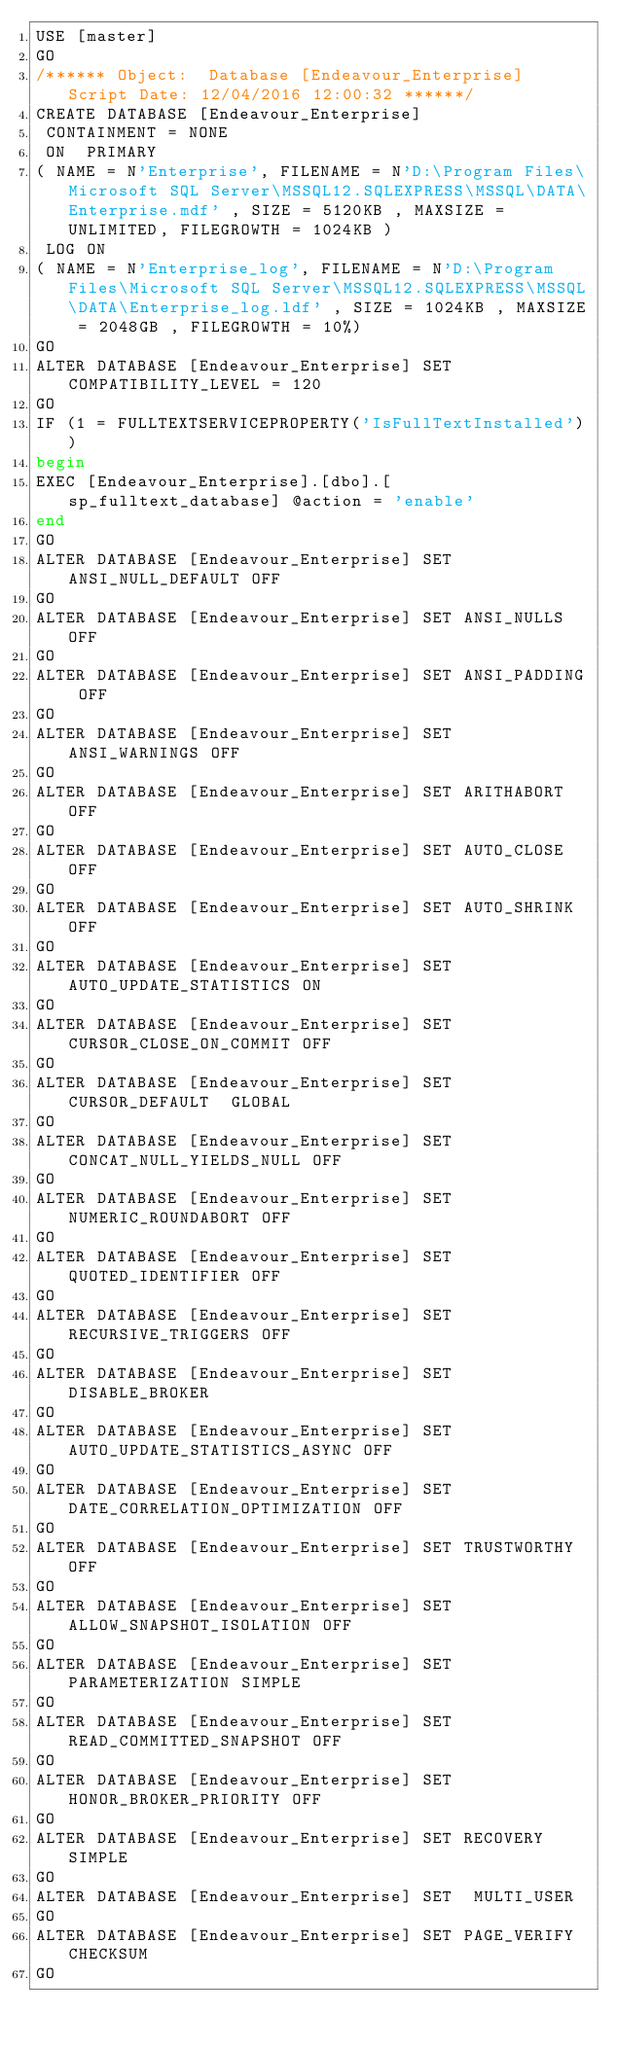<code> <loc_0><loc_0><loc_500><loc_500><_SQL_>USE [master]
GO
/****** Object:  Database [Endeavour_Enterprise]    Script Date: 12/04/2016 12:00:32 ******/
CREATE DATABASE [Endeavour_Enterprise]
 CONTAINMENT = NONE
 ON  PRIMARY 
( NAME = N'Enterprise', FILENAME = N'D:\Program Files\Microsoft SQL Server\MSSQL12.SQLEXPRESS\MSSQL\DATA\Enterprise.mdf' , SIZE = 5120KB , MAXSIZE = UNLIMITED, FILEGROWTH = 1024KB )
 LOG ON 
( NAME = N'Enterprise_log', FILENAME = N'D:\Program Files\Microsoft SQL Server\MSSQL12.SQLEXPRESS\MSSQL\DATA\Enterprise_log.ldf' , SIZE = 1024KB , MAXSIZE = 2048GB , FILEGROWTH = 10%)
GO
ALTER DATABASE [Endeavour_Enterprise] SET COMPATIBILITY_LEVEL = 120
GO
IF (1 = FULLTEXTSERVICEPROPERTY('IsFullTextInstalled'))
begin
EXEC [Endeavour_Enterprise].[dbo].[sp_fulltext_database] @action = 'enable'
end
GO
ALTER DATABASE [Endeavour_Enterprise] SET ANSI_NULL_DEFAULT OFF 
GO
ALTER DATABASE [Endeavour_Enterprise] SET ANSI_NULLS OFF 
GO
ALTER DATABASE [Endeavour_Enterprise] SET ANSI_PADDING OFF 
GO
ALTER DATABASE [Endeavour_Enterprise] SET ANSI_WARNINGS OFF 
GO
ALTER DATABASE [Endeavour_Enterprise] SET ARITHABORT OFF 
GO
ALTER DATABASE [Endeavour_Enterprise] SET AUTO_CLOSE OFF 
GO
ALTER DATABASE [Endeavour_Enterprise] SET AUTO_SHRINK OFF 
GO
ALTER DATABASE [Endeavour_Enterprise] SET AUTO_UPDATE_STATISTICS ON 
GO
ALTER DATABASE [Endeavour_Enterprise] SET CURSOR_CLOSE_ON_COMMIT OFF 
GO
ALTER DATABASE [Endeavour_Enterprise] SET CURSOR_DEFAULT  GLOBAL 
GO
ALTER DATABASE [Endeavour_Enterprise] SET CONCAT_NULL_YIELDS_NULL OFF 
GO
ALTER DATABASE [Endeavour_Enterprise] SET NUMERIC_ROUNDABORT OFF 
GO
ALTER DATABASE [Endeavour_Enterprise] SET QUOTED_IDENTIFIER OFF 
GO
ALTER DATABASE [Endeavour_Enterprise] SET RECURSIVE_TRIGGERS OFF 
GO
ALTER DATABASE [Endeavour_Enterprise] SET  DISABLE_BROKER 
GO
ALTER DATABASE [Endeavour_Enterprise] SET AUTO_UPDATE_STATISTICS_ASYNC OFF 
GO
ALTER DATABASE [Endeavour_Enterprise] SET DATE_CORRELATION_OPTIMIZATION OFF 
GO
ALTER DATABASE [Endeavour_Enterprise] SET TRUSTWORTHY OFF 
GO
ALTER DATABASE [Endeavour_Enterprise] SET ALLOW_SNAPSHOT_ISOLATION OFF 
GO
ALTER DATABASE [Endeavour_Enterprise] SET PARAMETERIZATION SIMPLE 
GO
ALTER DATABASE [Endeavour_Enterprise] SET READ_COMMITTED_SNAPSHOT OFF 
GO
ALTER DATABASE [Endeavour_Enterprise] SET HONOR_BROKER_PRIORITY OFF 
GO
ALTER DATABASE [Endeavour_Enterprise] SET RECOVERY SIMPLE 
GO
ALTER DATABASE [Endeavour_Enterprise] SET  MULTI_USER 
GO
ALTER DATABASE [Endeavour_Enterprise] SET PAGE_VERIFY CHECKSUM  
GO</code> 